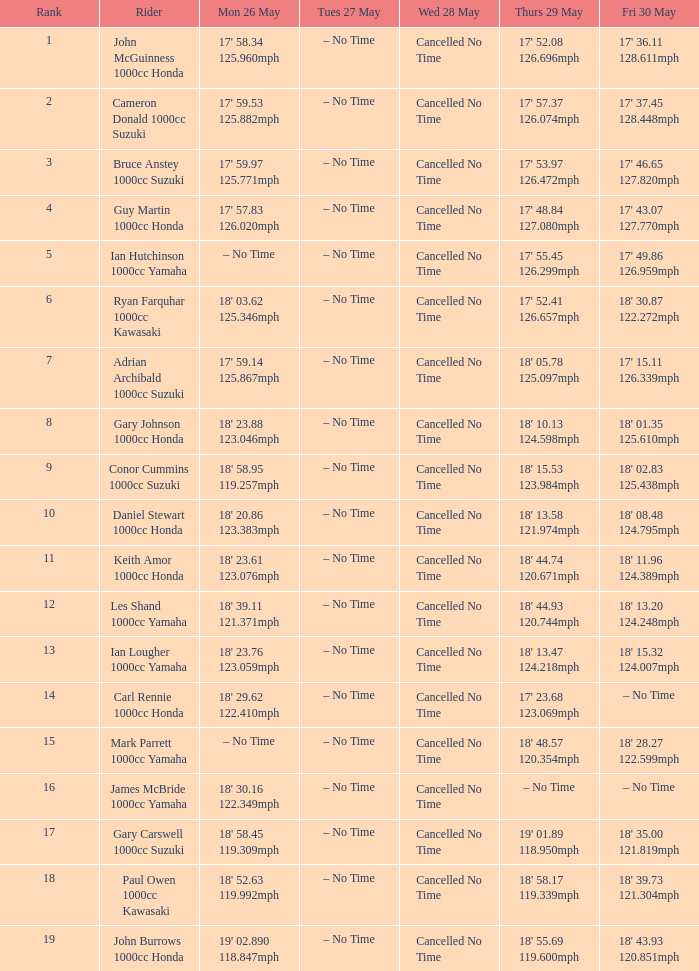What is the quantity for fri may 30 and mon may 26 is 19' 0 18' 43.93 120.851mph. 